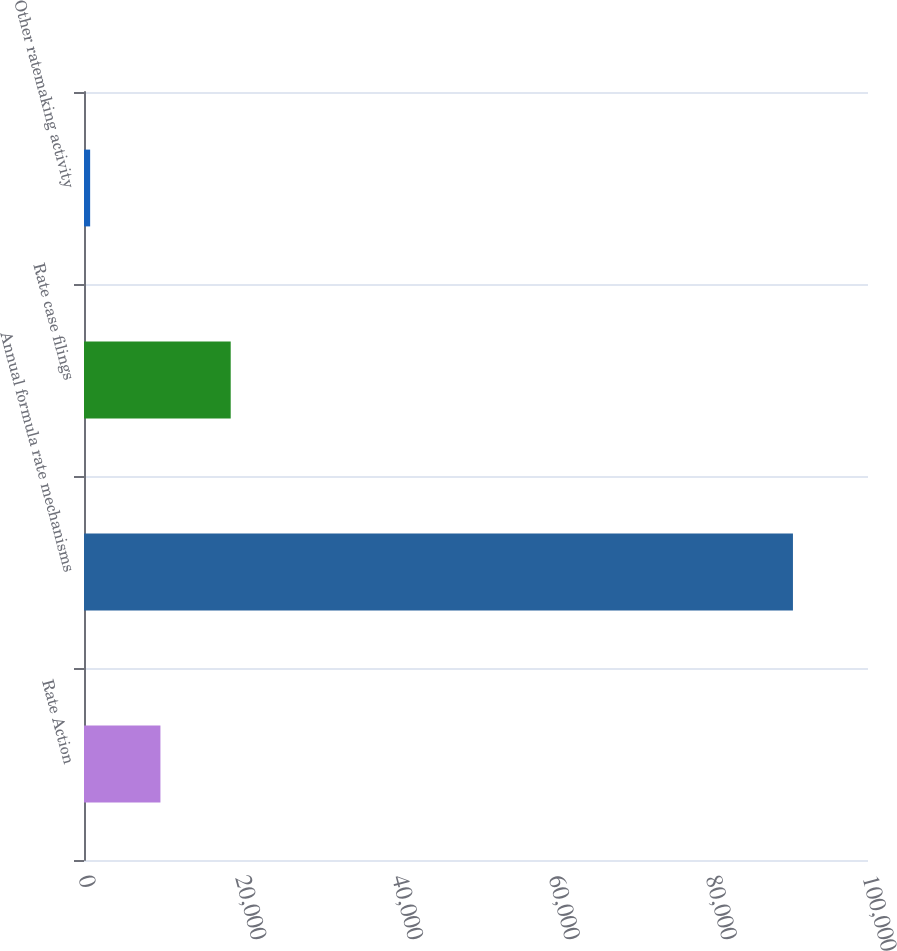<chart> <loc_0><loc_0><loc_500><loc_500><bar_chart><fcel>Rate Action<fcel>Annual formula rate mechanisms<fcel>Rate case filings<fcel>Other ratemaking activity<nl><fcel>9748.3<fcel>90427<fcel>18712.6<fcel>784<nl></chart> 